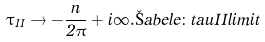Convert formula to latex. <formula><loc_0><loc_0><loc_500><loc_500>\tau _ { I I } \to - \frac { n } { 2 \pi } + i \infty . \L a b e l { e \colon t a u I I l i m i t }</formula> 